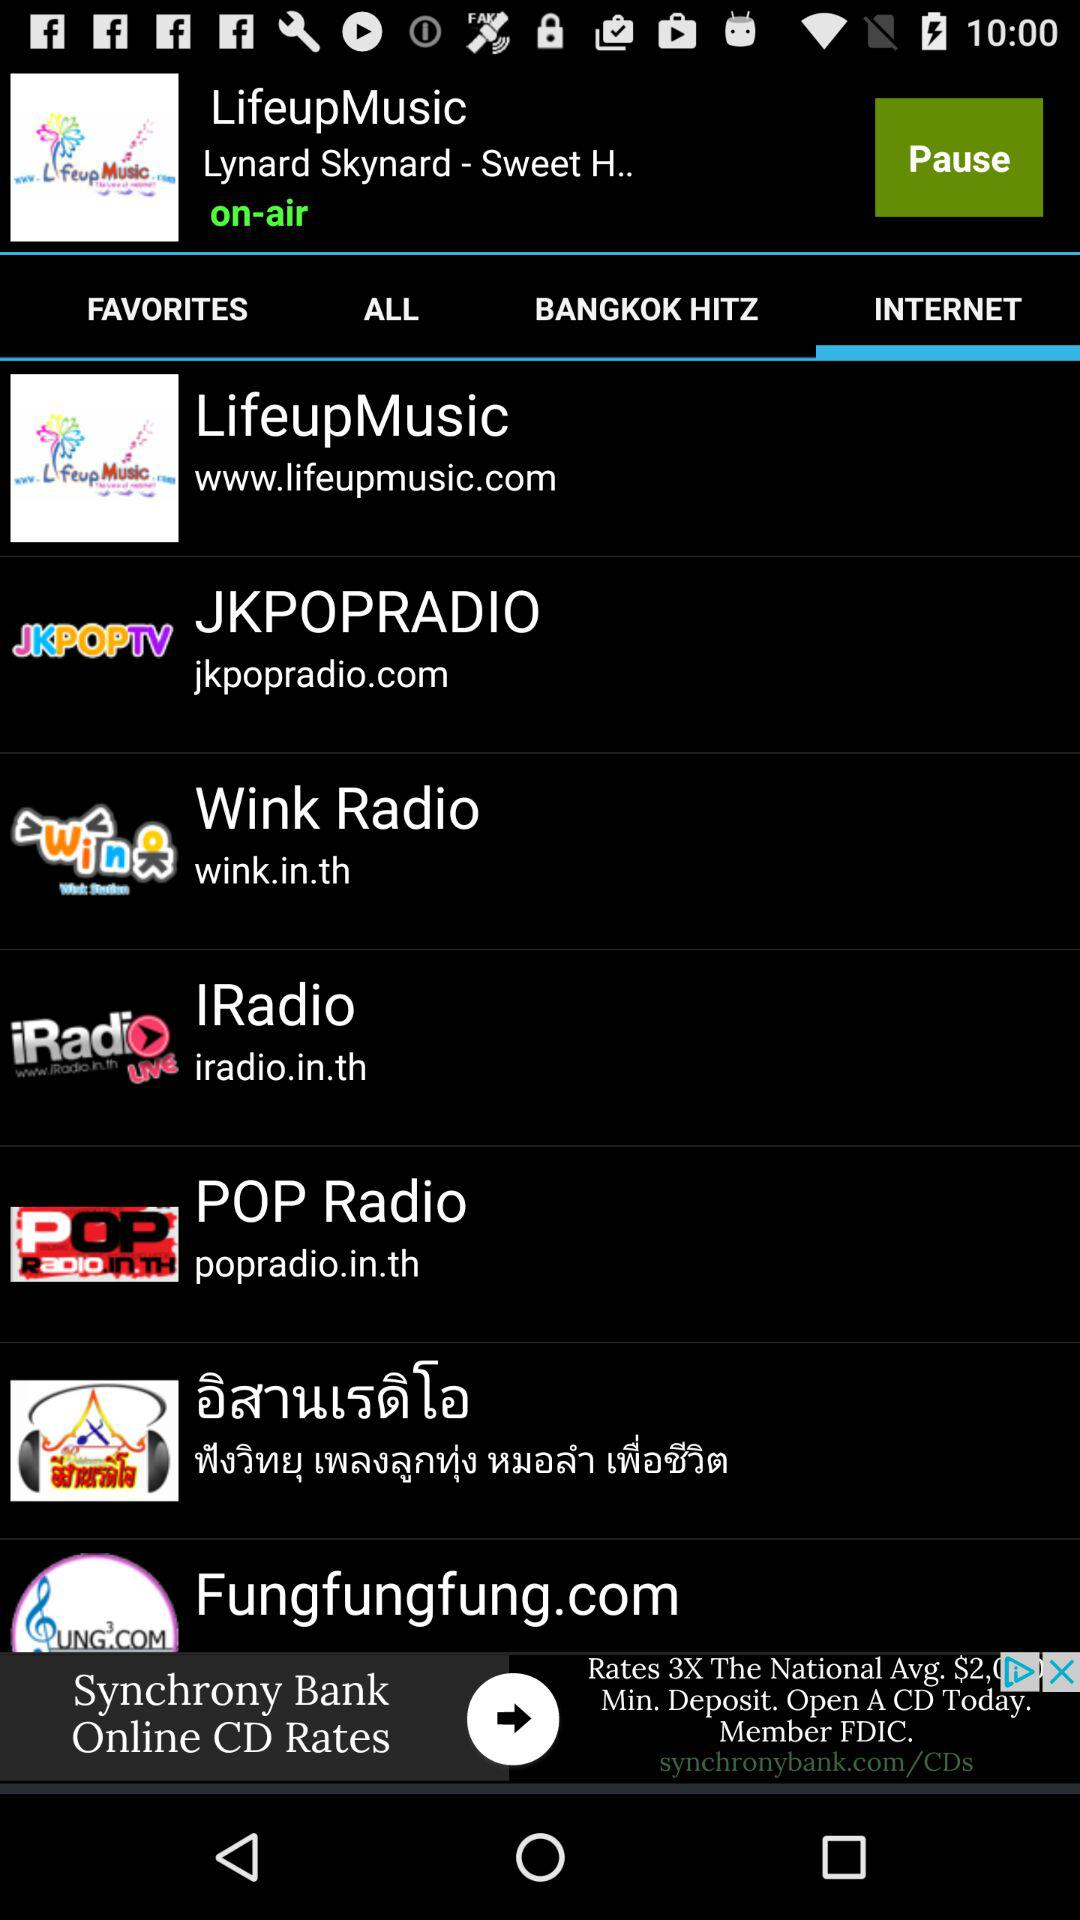Which tab has been selected? The tab that has been selected is "INTERNET". 